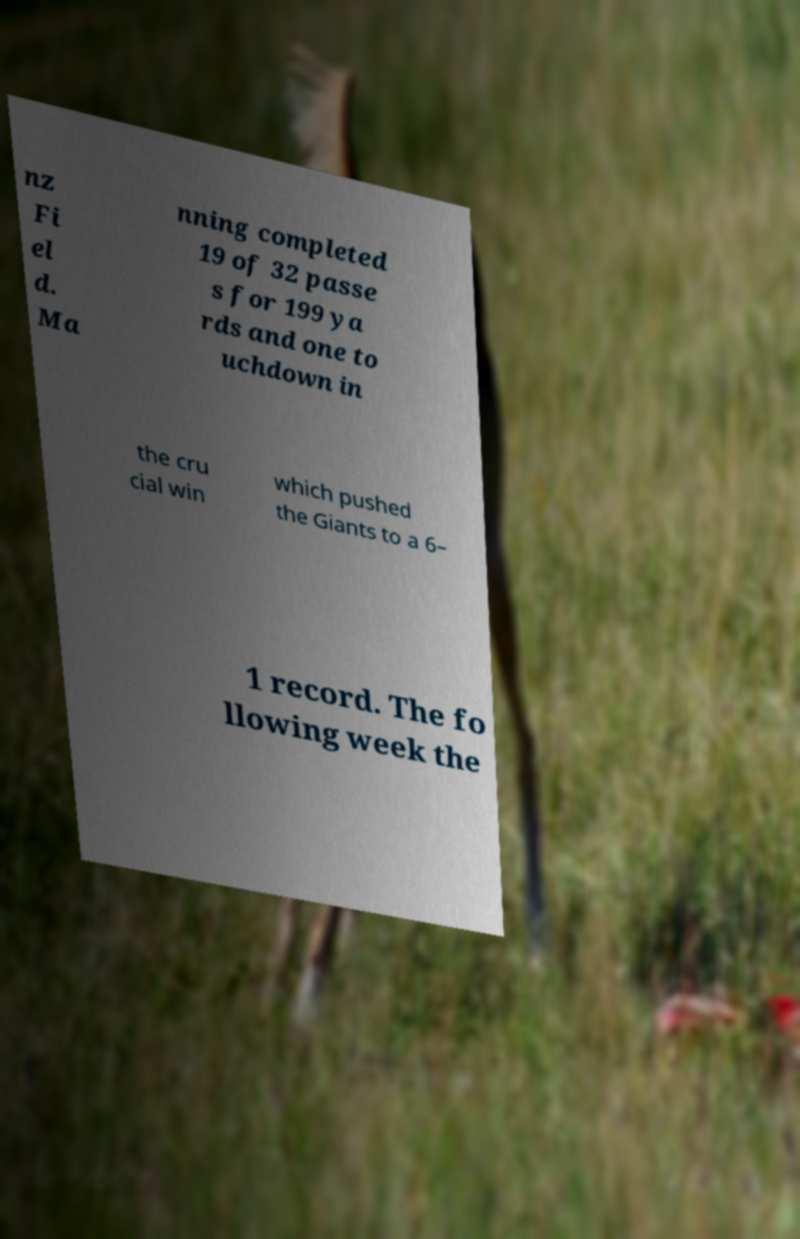Could you extract and type out the text from this image? nz Fi el d. Ma nning completed 19 of 32 passe s for 199 ya rds and one to uchdown in the cru cial win which pushed the Giants to a 6– 1 record. The fo llowing week the 